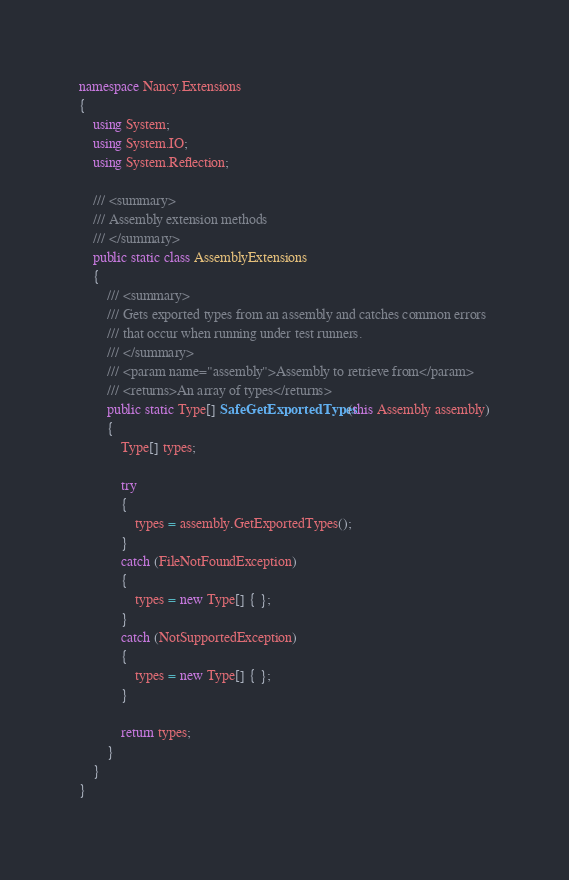<code> <loc_0><loc_0><loc_500><loc_500><_C#_>namespace Nancy.Extensions
{
    using System;
    using System.IO;
    using System.Reflection;

    /// <summary>
    /// Assembly extension methods
    /// </summary>
    public static class AssemblyExtensions
    {
        /// <summary>
        /// Gets exported types from an assembly and catches common errors
        /// that occur when running under test runners.
        /// </summary>
        /// <param name="assembly">Assembly to retrieve from</param>
        /// <returns>An array of types</returns>
        public static Type[] SafeGetExportedTypes(this Assembly assembly)
        {
            Type[] types;

            try
            {
                types = assembly.GetExportedTypes();
            }
            catch (FileNotFoundException)
            {
                types = new Type[] { };
            }
            catch (NotSupportedException)
            {
                types = new Type[] { };
            }

            return types;
        }
    }
}
</code> 